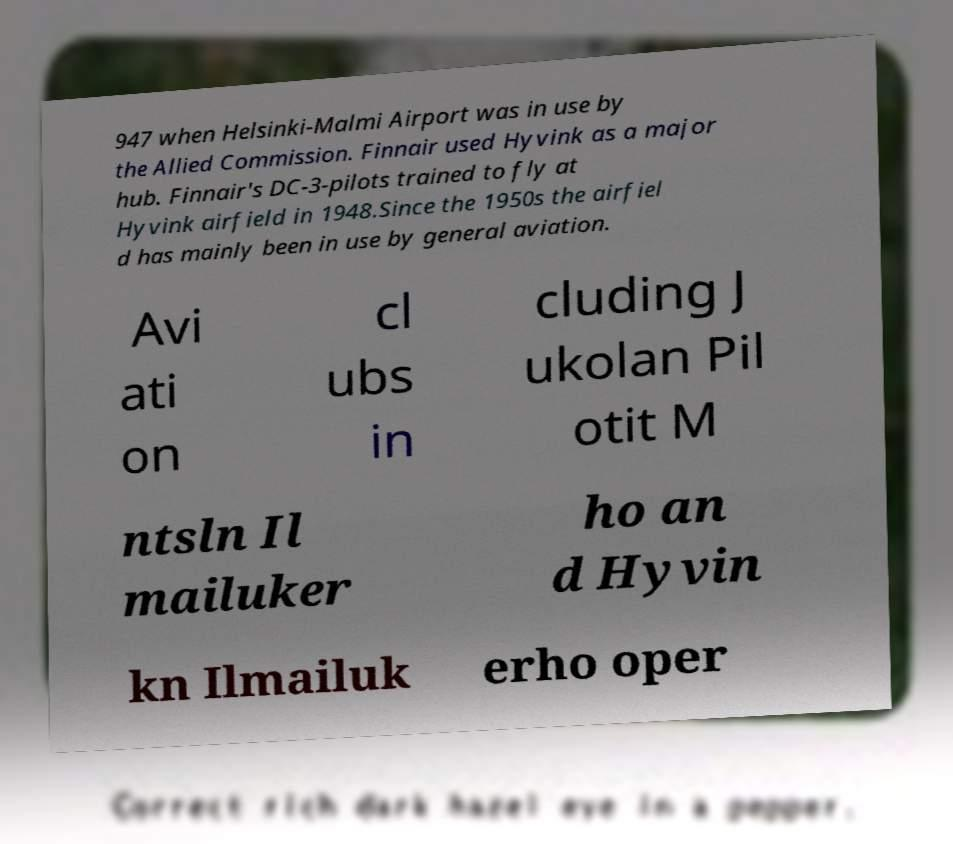What messages or text are displayed in this image? I need them in a readable, typed format. 947 when Helsinki-Malmi Airport was in use by the Allied Commission. Finnair used Hyvink as a major hub. Finnair's DC-3-pilots trained to fly at Hyvink airfield in 1948.Since the 1950s the airfiel d has mainly been in use by general aviation. Avi ati on cl ubs in cluding J ukolan Pil otit M ntsln Il mailuker ho an d Hyvin kn Ilmailuk erho oper 